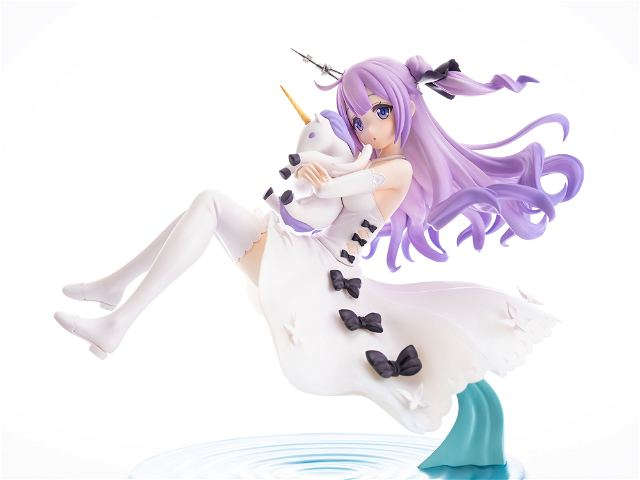Considering the use of bows in her attire, how do they enhance the thematic elements of the character’s design? The black bows used in her attire serve not just as decorative elements but also as thematic enhancers that contribute to the narrative of delicacy and detail in her magical universe. The bows could symbolize the tying together of various elements within her world—binding magic, reality, and perhaps other entities. These design choices subtly suggest that she might play a role where balance and cohesion in her mystical realm are crucial, as she might be involved in maintaining harmony or sealing magical bonds. 